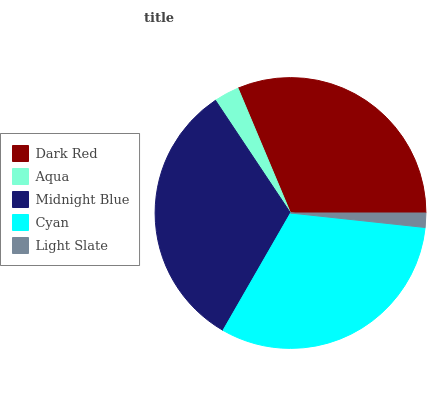Is Light Slate the minimum?
Answer yes or no. Yes. Is Midnight Blue the maximum?
Answer yes or no. Yes. Is Aqua the minimum?
Answer yes or no. No. Is Aqua the maximum?
Answer yes or no. No. Is Dark Red greater than Aqua?
Answer yes or no. Yes. Is Aqua less than Dark Red?
Answer yes or no. Yes. Is Aqua greater than Dark Red?
Answer yes or no. No. Is Dark Red less than Aqua?
Answer yes or no. No. Is Dark Red the high median?
Answer yes or no. Yes. Is Dark Red the low median?
Answer yes or no. Yes. Is Midnight Blue the high median?
Answer yes or no. No. Is Aqua the low median?
Answer yes or no. No. 